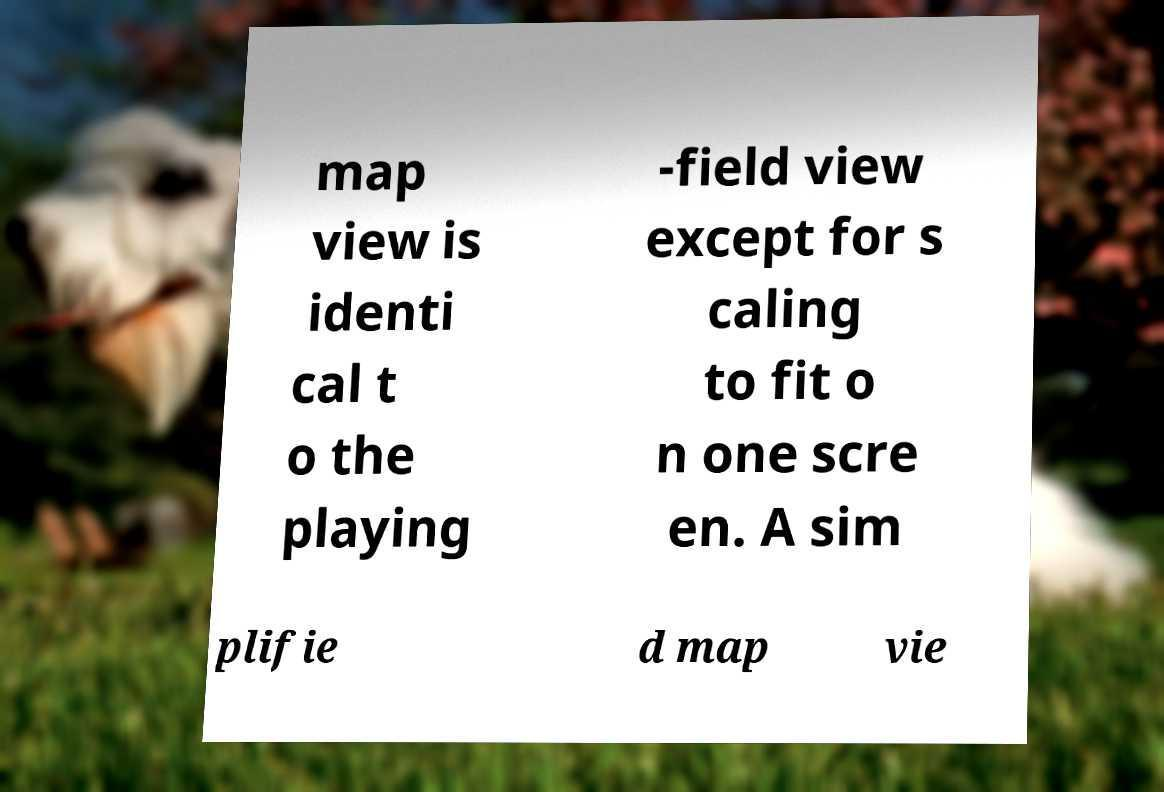There's text embedded in this image that I need extracted. Can you transcribe it verbatim? map view is identi cal t o the playing -field view except for s caling to fit o n one scre en. A sim plifie d map vie 